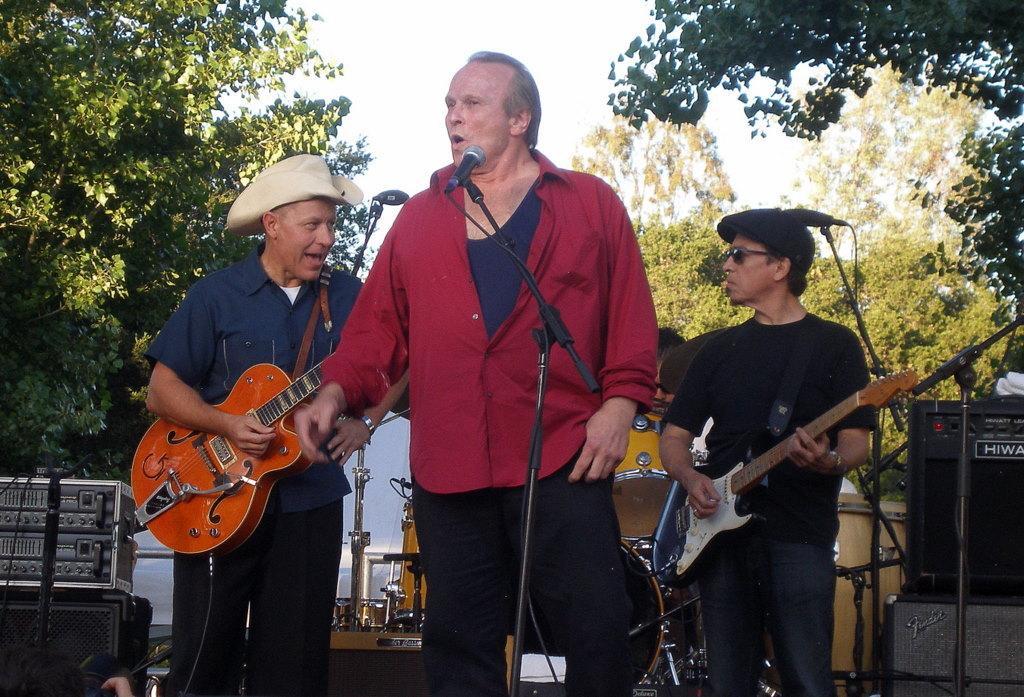Please provide a concise description of this image. In this image, There are three persons standing and wearing colorful clothes. These two persons are playing a guitar and wearing a hats on their head. This person is standing in front of this mic. There are some musical instruments behind these persons. There are some trees behind these persons. There is a sky at the top. 